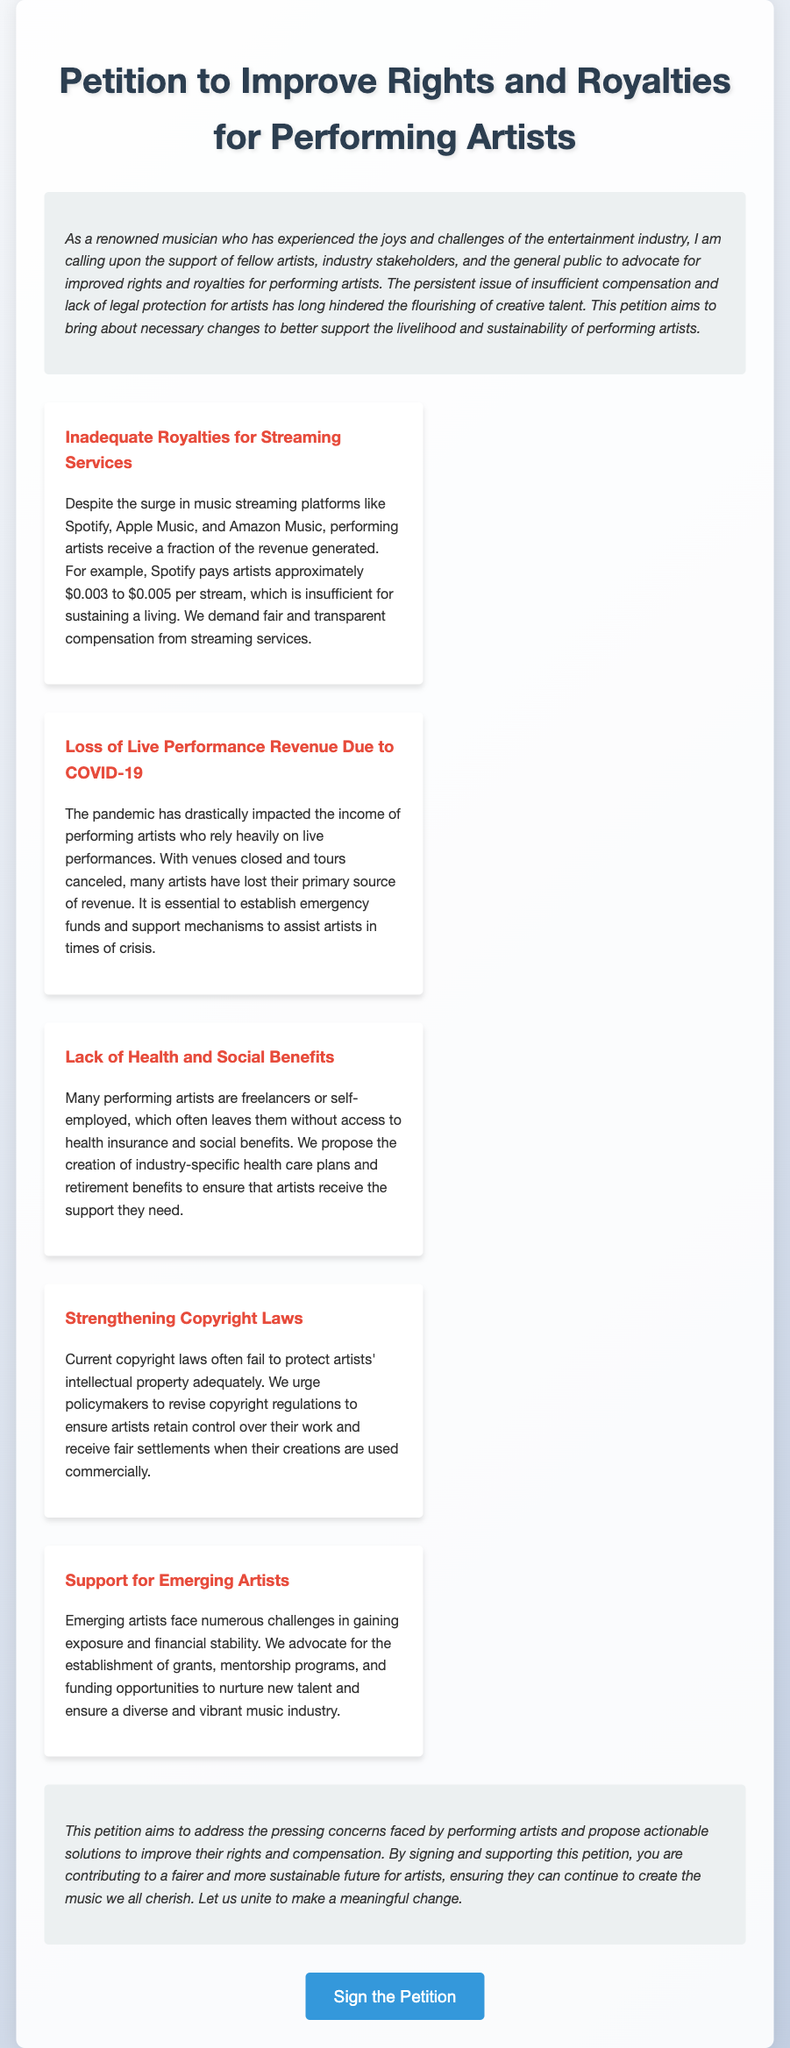What is the title of the petition? The title of the petition is stated prominently at the top of the document.
Answer: Petition to Improve Rights and Royalties for Performing Artists How much does Spotify pay artists per stream? The document specifies the amount paid by Spotify to artists per stream as a range in one of its main points.
Answer: $0.003 to $0.005 What has drastically impacted the income of performing artists? The document mentions a specific event that has drastically affected artists' income, detailed in one of the points.
Answer: COVID-19 What is proposed to assist artists during times of crisis? The document suggests an initiative aimed at supporting artists during emergencies in one of its points.
Answer: Emergency funds What do many performing artists lack according to the petition? The petition highlights a common issue faced by performing artists in terms of financial security.
Answer: Health insurance What is one benefit proposed for emerging artists? The document states several forms of support that could be beneficial for new artists contained within one of the main points.
Answer: Grants What is a suggested change to copyright laws? The petition urges a specific action regarding copyright laws to protect artists' work, which is articulated in one of the points.
Answer: Strengthening copyright laws What type of artists does the petition advocate to support? The petition identifies a specific group of artists it aims to support, explicitly mentioned in the main points section.
Answer: Emerging artists What does signing the petition contribute to? The conclusion of the document summarizes the ultimate goal of the petition for those who choose to support it.
Answer: A fairer and more sustainable future for artists 